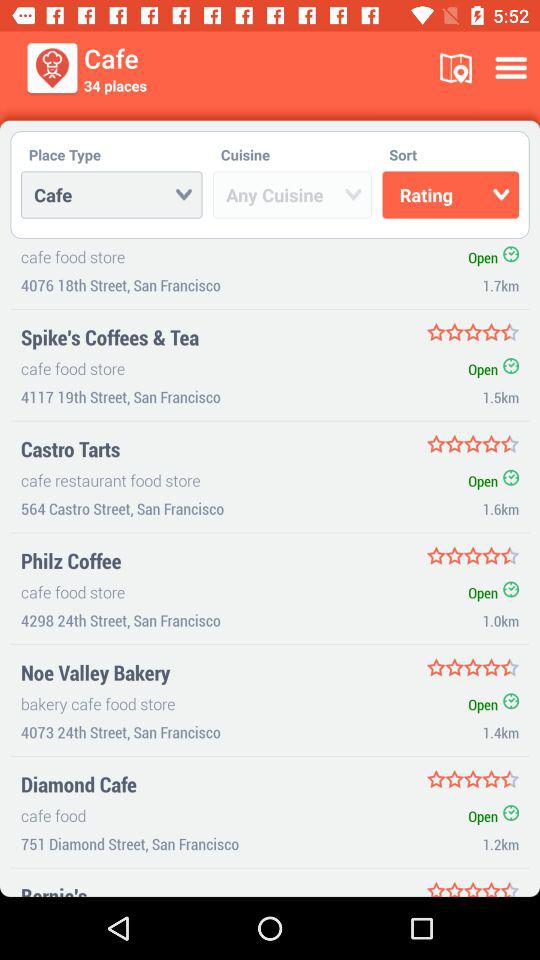What is the rating of "Castro Tarts"? The rating is 4.5 stars. 